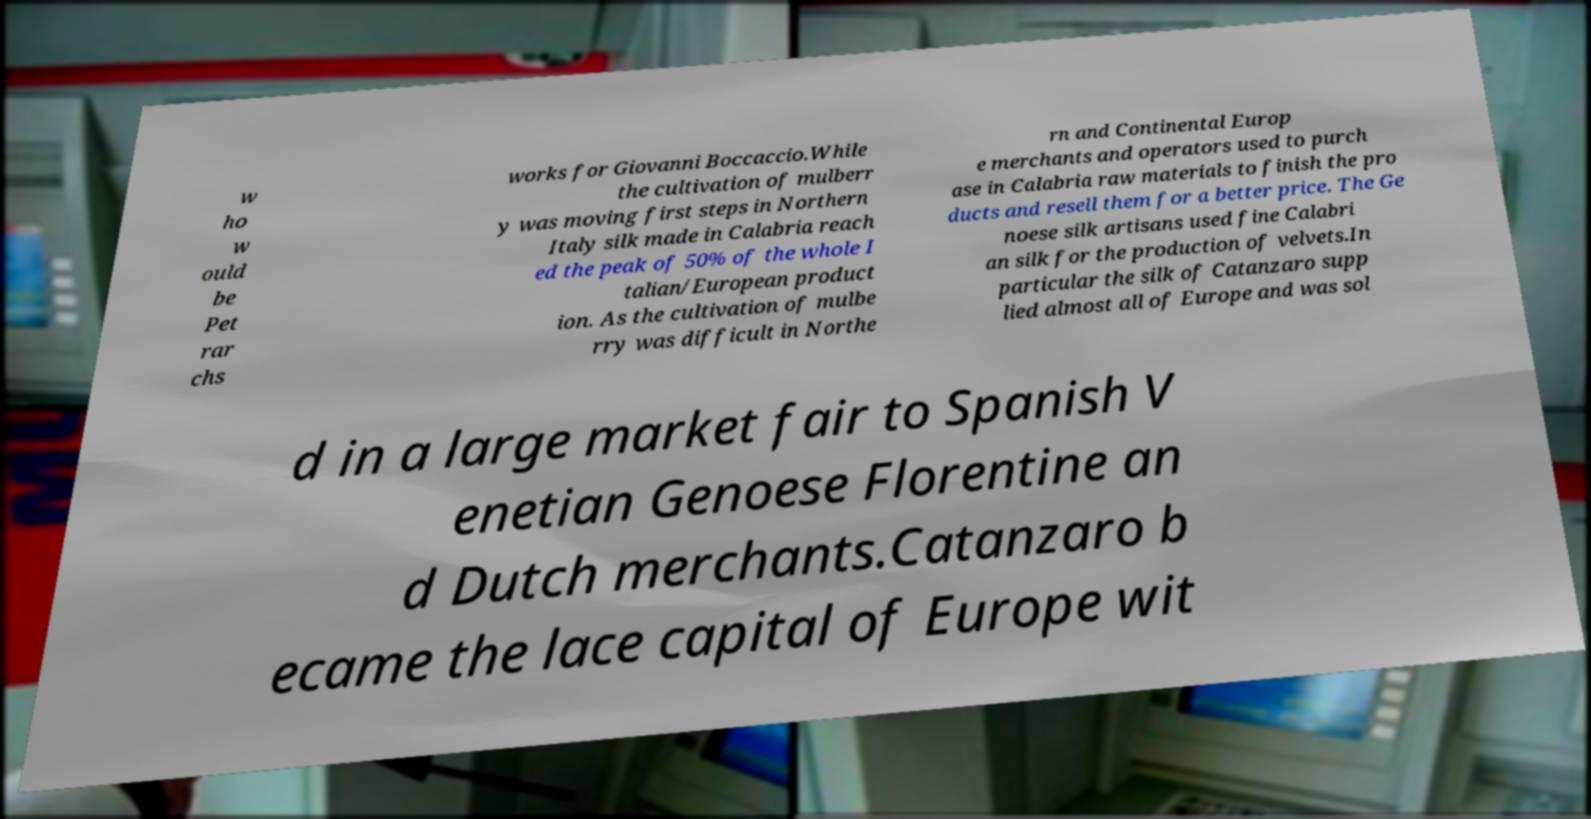Could you extract and type out the text from this image? w ho w ould be Pet rar chs works for Giovanni Boccaccio.While the cultivation of mulberr y was moving first steps in Northern Italy silk made in Calabria reach ed the peak of 50% of the whole I talian/European product ion. As the cultivation of mulbe rry was difficult in Northe rn and Continental Europ e merchants and operators used to purch ase in Calabria raw materials to finish the pro ducts and resell them for a better price. The Ge noese silk artisans used fine Calabri an silk for the production of velvets.In particular the silk of Catanzaro supp lied almost all of Europe and was sol d in a large market fair to Spanish V enetian Genoese Florentine an d Dutch merchants.Catanzaro b ecame the lace capital of Europe wit 